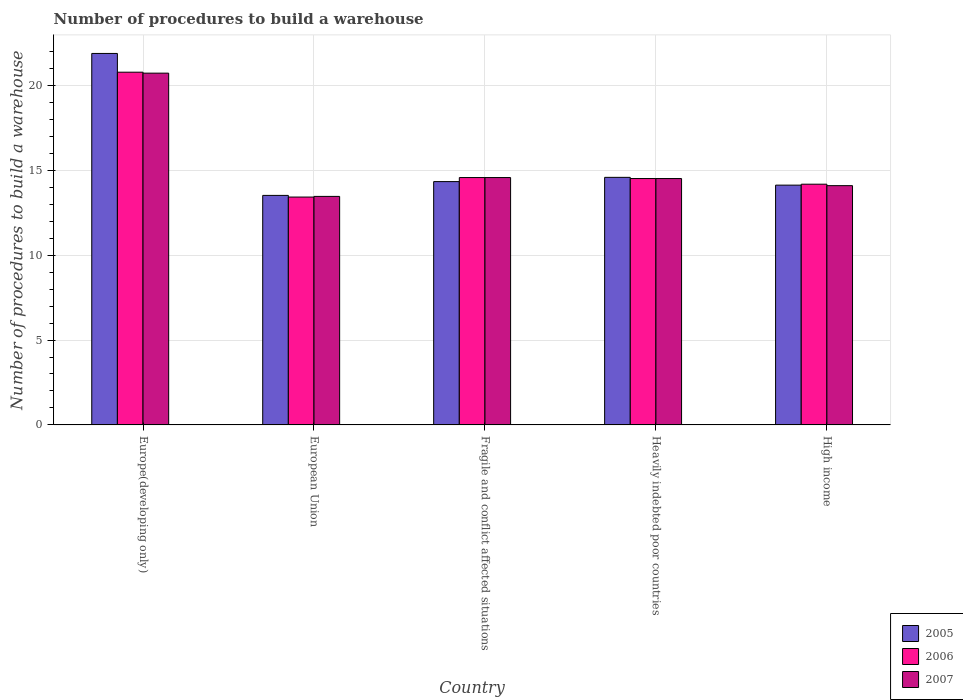How many bars are there on the 2nd tick from the left?
Offer a terse response. 3. What is the number of procedures to build a warehouse in in 2005 in Fragile and conflict affected situations?
Offer a very short reply. 14.33. Across all countries, what is the maximum number of procedures to build a warehouse in in 2007?
Provide a succinct answer. 20.72. Across all countries, what is the minimum number of procedures to build a warehouse in in 2005?
Offer a terse response. 13.52. In which country was the number of procedures to build a warehouse in in 2007 maximum?
Give a very brief answer. Europe(developing only). What is the total number of procedures to build a warehouse in in 2007 in the graph?
Give a very brief answer. 77.36. What is the difference between the number of procedures to build a warehouse in in 2007 in European Union and that in Fragile and conflict affected situations?
Offer a very short reply. -1.11. What is the difference between the number of procedures to build a warehouse in in 2007 in European Union and the number of procedures to build a warehouse in in 2005 in Fragile and conflict affected situations?
Offer a very short reply. -0.87. What is the average number of procedures to build a warehouse in in 2006 per country?
Provide a short and direct response. 15.49. What is the difference between the number of procedures to build a warehouse in of/in 2005 and number of procedures to build a warehouse in of/in 2007 in Heavily indebted poor countries?
Your answer should be very brief. 0.07. In how many countries, is the number of procedures to build a warehouse in in 2006 greater than 18?
Offer a very short reply. 1. What is the ratio of the number of procedures to build a warehouse in in 2005 in European Union to that in Fragile and conflict affected situations?
Your response must be concise. 0.94. Is the number of procedures to build a warehouse in in 2007 in Fragile and conflict affected situations less than that in Heavily indebted poor countries?
Provide a short and direct response. No. What is the difference between the highest and the second highest number of procedures to build a warehouse in in 2006?
Provide a short and direct response. 6.21. What is the difference between the highest and the lowest number of procedures to build a warehouse in in 2006?
Provide a short and direct response. 7.35. What does the 2nd bar from the right in European Union represents?
Your response must be concise. 2006. Is it the case that in every country, the sum of the number of procedures to build a warehouse in in 2005 and number of procedures to build a warehouse in in 2007 is greater than the number of procedures to build a warehouse in in 2006?
Offer a very short reply. Yes. Are all the bars in the graph horizontal?
Ensure brevity in your answer.  No. How many countries are there in the graph?
Your answer should be compact. 5. What is the difference between two consecutive major ticks on the Y-axis?
Provide a succinct answer. 5. Where does the legend appear in the graph?
Provide a succinct answer. Bottom right. What is the title of the graph?
Your answer should be compact. Number of procedures to build a warehouse. Does "1965" appear as one of the legend labels in the graph?
Your response must be concise. No. What is the label or title of the Y-axis?
Your response must be concise. Number of procedures to build a warehouse. What is the Number of procedures to build a warehouse in 2005 in Europe(developing only)?
Provide a succinct answer. 21.88. What is the Number of procedures to build a warehouse of 2006 in Europe(developing only)?
Provide a succinct answer. 20.78. What is the Number of procedures to build a warehouse in 2007 in Europe(developing only)?
Offer a terse response. 20.72. What is the Number of procedures to build a warehouse of 2005 in European Union?
Your answer should be very brief. 13.52. What is the Number of procedures to build a warehouse of 2006 in European Union?
Your response must be concise. 13.42. What is the Number of procedures to build a warehouse in 2007 in European Union?
Keep it short and to the point. 13.46. What is the Number of procedures to build a warehouse of 2005 in Fragile and conflict affected situations?
Give a very brief answer. 14.33. What is the Number of procedures to build a warehouse in 2006 in Fragile and conflict affected situations?
Provide a succinct answer. 14.57. What is the Number of procedures to build a warehouse of 2007 in Fragile and conflict affected situations?
Ensure brevity in your answer.  14.57. What is the Number of procedures to build a warehouse of 2005 in Heavily indebted poor countries?
Make the answer very short. 14.58. What is the Number of procedures to build a warehouse in 2006 in Heavily indebted poor countries?
Your answer should be very brief. 14.51. What is the Number of procedures to build a warehouse in 2007 in Heavily indebted poor countries?
Ensure brevity in your answer.  14.51. What is the Number of procedures to build a warehouse of 2005 in High income?
Offer a very short reply. 14.12. What is the Number of procedures to build a warehouse in 2006 in High income?
Keep it short and to the point. 14.18. What is the Number of procedures to build a warehouse of 2007 in High income?
Ensure brevity in your answer.  14.09. Across all countries, what is the maximum Number of procedures to build a warehouse of 2005?
Provide a short and direct response. 21.88. Across all countries, what is the maximum Number of procedures to build a warehouse of 2006?
Your response must be concise. 20.78. Across all countries, what is the maximum Number of procedures to build a warehouse in 2007?
Provide a short and direct response. 20.72. Across all countries, what is the minimum Number of procedures to build a warehouse of 2005?
Your response must be concise. 13.52. Across all countries, what is the minimum Number of procedures to build a warehouse of 2006?
Offer a very short reply. 13.42. Across all countries, what is the minimum Number of procedures to build a warehouse in 2007?
Give a very brief answer. 13.46. What is the total Number of procedures to build a warehouse of 2005 in the graph?
Your response must be concise. 78.44. What is the total Number of procedures to build a warehouse of 2006 in the graph?
Give a very brief answer. 77.47. What is the total Number of procedures to build a warehouse in 2007 in the graph?
Provide a short and direct response. 77.36. What is the difference between the Number of procedures to build a warehouse in 2005 in Europe(developing only) and that in European Union?
Keep it short and to the point. 8.36. What is the difference between the Number of procedures to build a warehouse of 2006 in Europe(developing only) and that in European Union?
Your answer should be very brief. 7.35. What is the difference between the Number of procedures to build a warehouse in 2007 in Europe(developing only) and that in European Union?
Offer a very short reply. 7.26. What is the difference between the Number of procedures to build a warehouse of 2005 in Europe(developing only) and that in Fragile and conflict affected situations?
Your response must be concise. 7.55. What is the difference between the Number of procedures to build a warehouse in 2006 in Europe(developing only) and that in Fragile and conflict affected situations?
Provide a short and direct response. 6.21. What is the difference between the Number of procedures to build a warehouse of 2007 in Europe(developing only) and that in Fragile and conflict affected situations?
Provide a short and direct response. 6.15. What is the difference between the Number of procedures to build a warehouse in 2005 in Europe(developing only) and that in Heavily indebted poor countries?
Your answer should be compact. 7.3. What is the difference between the Number of procedures to build a warehouse in 2006 in Europe(developing only) and that in Heavily indebted poor countries?
Provide a succinct answer. 6.26. What is the difference between the Number of procedures to build a warehouse in 2007 in Europe(developing only) and that in Heavily indebted poor countries?
Provide a succinct answer. 6.21. What is the difference between the Number of procedures to build a warehouse of 2005 in Europe(developing only) and that in High income?
Offer a terse response. 7.76. What is the difference between the Number of procedures to build a warehouse in 2006 in Europe(developing only) and that in High income?
Ensure brevity in your answer.  6.6. What is the difference between the Number of procedures to build a warehouse of 2007 in Europe(developing only) and that in High income?
Keep it short and to the point. 6.63. What is the difference between the Number of procedures to build a warehouse in 2005 in European Union and that in Fragile and conflict affected situations?
Offer a very short reply. -0.81. What is the difference between the Number of procedures to build a warehouse of 2006 in European Union and that in Fragile and conflict affected situations?
Your response must be concise. -1.15. What is the difference between the Number of procedures to build a warehouse of 2007 in European Union and that in Fragile and conflict affected situations?
Provide a succinct answer. -1.11. What is the difference between the Number of procedures to build a warehouse in 2005 in European Union and that in Heavily indebted poor countries?
Your response must be concise. -1.06. What is the difference between the Number of procedures to build a warehouse in 2006 in European Union and that in Heavily indebted poor countries?
Offer a terse response. -1.09. What is the difference between the Number of procedures to build a warehouse of 2007 in European Union and that in Heavily indebted poor countries?
Provide a short and direct response. -1.05. What is the difference between the Number of procedures to build a warehouse of 2005 in European Union and that in High income?
Provide a short and direct response. -0.6. What is the difference between the Number of procedures to build a warehouse of 2006 in European Union and that in High income?
Your response must be concise. -0.76. What is the difference between the Number of procedures to build a warehouse of 2007 in European Union and that in High income?
Your answer should be very brief. -0.63. What is the difference between the Number of procedures to build a warehouse in 2006 in Fragile and conflict affected situations and that in Heavily indebted poor countries?
Keep it short and to the point. 0.06. What is the difference between the Number of procedures to build a warehouse in 2007 in Fragile and conflict affected situations and that in Heavily indebted poor countries?
Your answer should be very brief. 0.06. What is the difference between the Number of procedures to build a warehouse of 2005 in Fragile and conflict affected situations and that in High income?
Keep it short and to the point. 0.21. What is the difference between the Number of procedures to build a warehouse of 2006 in Fragile and conflict affected situations and that in High income?
Give a very brief answer. 0.39. What is the difference between the Number of procedures to build a warehouse in 2007 in Fragile and conflict affected situations and that in High income?
Make the answer very short. 0.48. What is the difference between the Number of procedures to build a warehouse of 2005 in Heavily indebted poor countries and that in High income?
Your answer should be compact. 0.46. What is the difference between the Number of procedures to build a warehouse in 2006 in Heavily indebted poor countries and that in High income?
Make the answer very short. 0.33. What is the difference between the Number of procedures to build a warehouse of 2007 in Heavily indebted poor countries and that in High income?
Offer a very short reply. 0.42. What is the difference between the Number of procedures to build a warehouse in 2005 in Europe(developing only) and the Number of procedures to build a warehouse in 2006 in European Union?
Offer a terse response. 8.46. What is the difference between the Number of procedures to build a warehouse in 2005 in Europe(developing only) and the Number of procedures to build a warehouse in 2007 in European Union?
Offer a terse response. 8.42. What is the difference between the Number of procedures to build a warehouse of 2006 in Europe(developing only) and the Number of procedures to build a warehouse of 2007 in European Union?
Your answer should be compact. 7.32. What is the difference between the Number of procedures to build a warehouse in 2005 in Europe(developing only) and the Number of procedures to build a warehouse in 2006 in Fragile and conflict affected situations?
Your answer should be very brief. 7.31. What is the difference between the Number of procedures to build a warehouse in 2005 in Europe(developing only) and the Number of procedures to build a warehouse in 2007 in Fragile and conflict affected situations?
Your answer should be very brief. 7.31. What is the difference between the Number of procedures to build a warehouse in 2006 in Europe(developing only) and the Number of procedures to build a warehouse in 2007 in Fragile and conflict affected situations?
Your answer should be compact. 6.21. What is the difference between the Number of procedures to build a warehouse of 2005 in Europe(developing only) and the Number of procedures to build a warehouse of 2006 in Heavily indebted poor countries?
Offer a terse response. 7.37. What is the difference between the Number of procedures to build a warehouse in 2005 in Europe(developing only) and the Number of procedures to build a warehouse in 2007 in Heavily indebted poor countries?
Your response must be concise. 7.37. What is the difference between the Number of procedures to build a warehouse in 2006 in Europe(developing only) and the Number of procedures to build a warehouse in 2007 in Heavily indebted poor countries?
Offer a very short reply. 6.26. What is the difference between the Number of procedures to build a warehouse in 2005 in Europe(developing only) and the Number of procedures to build a warehouse in 2006 in High income?
Provide a short and direct response. 7.7. What is the difference between the Number of procedures to build a warehouse of 2005 in Europe(developing only) and the Number of procedures to build a warehouse of 2007 in High income?
Provide a succinct answer. 7.79. What is the difference between the Number of procedures to build a warehouse of 2006 in Europe(developing only) and the Number of procedures to build a warehouse of 2007 in High income?
Offer a terse response. 6.68. What is the difference between the Number of procedures to build a warehouse in 2005 in European Union and the Number of procedures to build a warehouse in 2006 in Fragile and conflict affected situations?
Your answer should be compact. -1.05. What is the difference between the Number of procedures to build a warehouse in 2005 in European Union and the Number of procedures to build a warehouse in 2007 in Fragile and conflict affected situations?
Your response must be concise. -1.05. What is the difference between the Number of procedures to build a warehouse of 2006 in European Union and the Number of procedures to build a warehouse of 2007 in Fragile and conflict affected situations?
Offer a very short reply. -1.15. What is the difference between the Number of procedures to build a warehouse of 2005 in European Union and the Number of procedures to build a warehouse of 2006 in Heavily indebted poor countries?
Your response must be concise. -0.99. What is the difference between the Number of procedures to build a warehouse of 2005 in European Union and the Number of procedures to build a warehouse of 2007 in Heavily indebted poor countries?
Offer a very short reply. -0.99. What is the difference between the Number of procedures to build a warehouse in 2006 in European Union and the Number of procedures to build a warehouse in 2007 in Heavily indebted poor countries?
Offer a very short reply. -1.09. What is the difference between the Number of procedures to build a warehouse of 2005 in European Union and the Number of procedures to build a warehouse of 2006 in High income?
Your answer should be compact. -0.66. What is the difference between the Number of procedures to build a warehouse of 2005 in European Union and the Number of procedures to build a warehouse of 2007 in High income?
Ensure brevity in your answer.  -0.57. What is the difference between the Number of procedures to build a warehouse in 2006 in European Union and the Number of procedures to build a warehouse in 2007 in High income?
Provide a succinct answer. -0.67. What is the difference between the Number of procedures to build a warehouse in 2005 in Fragile and conflict affected situations and the Number of procedures to build a warehouse in 2006 in Heavily indebted poor countries?
Your answer should be compact. -0.18. What is the difference between the Number of procedures to build a warehouse of 2005 in Fragile and conflict affected situations and the Number of procedures to build a warehouse of 2007 in Heavily indebted poor countries?
Make the answer very short. -0.18. What is the difference between the Number of procedures to build a warehouse of 2006 in Fragile and conflict affected situations and the Number of procedures to build a warehouse of 2007 in Heavily indebted poor countries?
Give a very brief answer. 0.06. What is the difference between the Number of procedures to build a warehouse in 2005 in Fragile and conflict affected situations and the Number of procedures to build a warehouse in 2006 in High income?
Keep it short and to the point. 0.15. What is the difference between the Number of procedures to build a warehouse in 2005 in Fragile and conflict affected situations and the Number of procedures to build a warehouse in 2007 in High income?
Give a very brief answer. 0.24. What is the difference between the Number of procedures to build a warehouse of 2006 in Fragile and conflict affected situations and the Number of procedures to build a warehouse of 2007 in High income?
Your answer should be very brief. 0.48. What is the difference between the Number of procedures to build a warehouse in 2005 in Heavily indebted poor countries and the Number of procedures to build a warehouse in 2006 in High income?
Your response must be concise. 0.4. What is the difference between the Number of procedures to build a warehouse in 2005 in Heavily indebted poor countries and the Number of procedures to build a warehouse in 2007 in High income?
Your answer should be compact. 0.49. What is the difference between the Number of procedures to build a warehouse in 2006 in Heavily indebted poor countries and the Number of procedures to build a warehouse in 2007 in High income?
Offer a very short reply. 0.42. What is the average Number of procedures to build a warehouse in 2005 per country?
Offer a very short reply. 15.69. What is the average Number of procedures to build a warehouse in 2006 per country?
Your response must be concise. 15.49. What is the average Number of procedures to build a warehouse of 2007 per country?
Provide a short and direct response. 15.47. What is the difference between the Number of procedures to build a warehouse of 2005 and Number of procedures to build a warehouse of 2006 in Europe(developing only)?
Make the answer very short. 1.1. What is the difference between the Number of procedures to build a warehouse in 2005 and Number of procedures to build a warehouse in 2007 in Europe(developing only)?
Keep it short and to the point. 1.16. What is the difference between the Number of procedures to build a warehouse of 2006 and Number of procedures to build a warehouse of 2007 in Europe(developing only)?
Provide a succinct answer. 0.06. What is the difference between the Number of procedures to build a warehouse of 2005 and Number of procedures to build a warehouse of 2006 in European Union?
Provide a short and direct response. 0.1. What is the difference between the Number of procedures to build a warehouse in 2005 and Number of procedures to build a warehouse in 2007 in European Union?
Your answer should be very brief. 0.06. What is the difference between the Number of procedures to build a warehouse of 2006 and Number of procedures to build a warehouse of 2007 in European Union?
Offer a terse response. -0.04. What is the difference between the Number of procedures to build a warehouse of 2005 and Number of procedures to build a warehouse of 2006 in Fragile and conflict affected situations?
Ensure brevity in your answer.  -0.24. What is the difference between the Number of procedures to build a warehouse of 2005 and Number of procedures to build a warehouse of 2007 in Fragile and conflict affected situations?
Your answer should be compact. -0.24. What is the difference between the Number of procedures to build a warehouse in 2006 and Number of procedures to build a warehouse in 2007 in Fragile and conflict affected situations?
Keep it short and to the point. 0. What is the difference between the Number of procedures to build a warehouse of 2005 and Number of procedures to build a warehouse of 2006 in Heavily indebted poor countries?
Give a very brief answer. 0.07. What is the difference between the Number of procedures to build a warehouse of 2005 and Number of procedures to build a warehouse of 2007 in Heavily indebted poor countries?
Your answer should be very brief. 0.07. What is the difference between the Number of procedures to build a warehouse of 2005 and Number of procedures to build a warehouse of 2006 in High income?
Your answer should be very brief. -0.06. What is the difference between the Number of procedures to build a warehouse of 2005 and Number of procedures to build a warehouse of 2007 in High income?
Your response must be concise. 0.03. What is the difference between the Number of procedures to build a warehouse in 2006 and Number of procedures to build a warehouse in 2007 in High income?
Provide a succinct answer. 0.09. What is the ratio of the Number of procedures to build a warehouse in 2005 in Europe(developing only) to that in European Union?
Provide a short and direct response. 1.62. What is the ratio of the Number of procedures to build a warehouse in 2006 in Europe(developing only) to that in European Union?
Keep it short and to the point. 1.55. What is the ratio of the Number of procedures to build a warehouse in 2007 in Europe(developing only) to that in European Union?
Ensure brevity in your answer.  1.54. What is the ratio of the Number of procedures to build a warehouse of 2005 in Europe(developing only) to that in Fragile and conflict affected situations?
Your answer should be compact. 1.53. What is the ratio of the Number of procedures to build a warehouse in 2006 in Europe(developing only) to that in Fragile and conflict affected situations?
Keep it short and to the point. 1.43. What is the ratio of the Number of procedures to build a warehouse of 2007 in Europe(developing only) to that in Fragile and conflict affected situations?
Provide a short and direct response. 1.42. What is the ratio of the Number of procedures to build a warehouse in 2005 in Europe(developing only) to that in Heavily indebted poor countries?
Offer a terse response. 1.5. What is the ratio of the Number of procedures to build a warehouse in 2006 in Europe(developing only) to that in Heavily indebted poor countries?
Give a very brief answer. 1.43. What is the ratio of the Number of procedures to build a warehouse in 2007 in Europe(developing only) to that in Heavily indebted poor countries?
Keep it short and to the point. 1.43. What is the ratio of the Number of procedures to build a warehouse of 2005 in Europe(developing only) to that in High income?
Offer a very short reply. 1.55. What is the ratio of the Number of procedures to build a warehouse in 2006 in Europe(developing only) to that in High income?
Your answer should be very brief. 1.47. What is the ratio of the Number of procedures to build a warehouse of 2007 in Europe(developing only) to that in High income?
Your answer should be compact. 1.47. What is the ratio of the Number of procedures to build a warehouse of 2005 in European Union to that in Fragile and conflict affected situations?
Your answer should be very brief. 0.94. What is the ratio of the Number of procedures to build a warehouse in 2006 in European Union to that in Fragile and conflict affected situations?
Ensure brevity in your answer.  0.92. What is the ratio of the Number of procedures to build a warehouse of 2007 in European Union to that in Fragile and conflict affected situations?
Give a very brief answer. 0.92. What is the ratio of the Number of procedures to build a warehouse of 2005 in European Union to that in Heavily indebted poor countries?
Offer a terse response. 0.93. What is the ratio of the Number of procedures to build a warehouse of 2006 in European Union to that in Heavily indebted poor countries?
Ensure brevity in your answer.  0.92. What is the ratio of the Number of procedures to build a warehouse in 2007 in European Union to that in Heavily indebted poor countries?
Offer a very short reply. 0.93. What is the ratio of the Number of procedures to build a warehouse of 2005 in European Union to that in High income?
Give a very brief answer. 0.96. What is the ratio of the Number of procedures to build a warehouse of 2006 in European Union to that in High income?
Provide a succinct answer. 0.95. What is the ratio of the Number of procedures to build a warehouse in 2007 in European Union to that in High income?
Provide a succinct answer. 0.96. What is the ratio of the Number of procedures to build a warehouse in 2005 in Fragile and conflict affected situations to that in Heavily indebted poor countries?
Provide a short and direct response. 0.98. What is the ratio of the Number of procedures to build a warehouse in 2006 in Fragile and conflict affected situations to that in Heavily indebted poor countries?
Offer a very short reply. 1. What is the ratio of the Number of procedures to build a warehouse of 2007 in Fragile and conflict affected situations to that in Heavily indebted poor countries?
Provide a short and direct response. 1. What is the ratio of the Number of procedures to build a warehouse in 2005 in Fragile and conflict affected situations to that in High income?
Offer a terse response. 1.01. What is the ratio of the Number of procedures to build a warehouse in 2006 in Fragile and conflict affected situations to that in High income?
Offer a terse response. 1.03. What is the ratio of the Number of procedures to build a warehouse in 2007 in Fragile and conflict affected situations to that in High income?
Provide a succinct answer. 1.03. What is the ratio of the Number of procedures to build a warehouse in 2005 in Heavily indebted poor countries to that in High income?
Provide a succinct answer. 1.03. What is the ratio of the Number of procedures to build a warehouse in 2006 in Heavily indebted poor countries to that in High income?
Ensure brevity in your answer.  1.02. What is the ratio of the Number of procedures to build a warehouse in 2007 in Heavily indebted poor countries to that in High income?
Make the answer very short. 1.03. What is the difference between the highest and the second highest Number of procedures to build a warehouse in 2005?
Provide a short and direct response. 7.3. What is the difference between the highest and the second highest Number of procedures to build a warehouse in 2006?
Make the answer very short. 6.21. What is the difference between the highest and the second highest Number of procedures to build a warehouse of 2007?
Ensure brevity in your answer.  6.15. What is the difference between the highest and the lowest Number of procedures to build a warehouse in 2005?
Provide a short and direct response. 8.36. What is the difference between the highest and the lowest Number of procedures to build a warehouse in 2006?
Offer a very short reply. 7.35. What is the difference between the highest and the lowest Number of procedures to build a warehouse in 2007?
Ensure brevity in your answer.  7.26. 